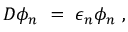<formula> <loc_0><loc_0><loc_500><loc_500>D \phi _ { n } \ = \ \epsilon _ { n } \phi _ { n } \ ,</formula> 